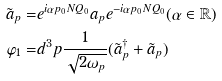Convert formula to latex. <formula><loc_0><loc_0><loc_500><loc_500>\tilde { a } _ { p } = & e ^ { i \alpha p _ { 0 } N Q _ { 0 } } a _ { p } e ^ { - i \alpha p _ { 0 } N Q _ { 0 } } ( \alpha \in \mathbb { R } ) \\ \varphi _ { 1 } = & d ^ { 3 } p \frac { 1 } { \sqrt { 2 \omega _ { p } } } ( \tilde { a } _ { p } ^ { \dagger } + \tilde { a } _ { p } )</formula> 